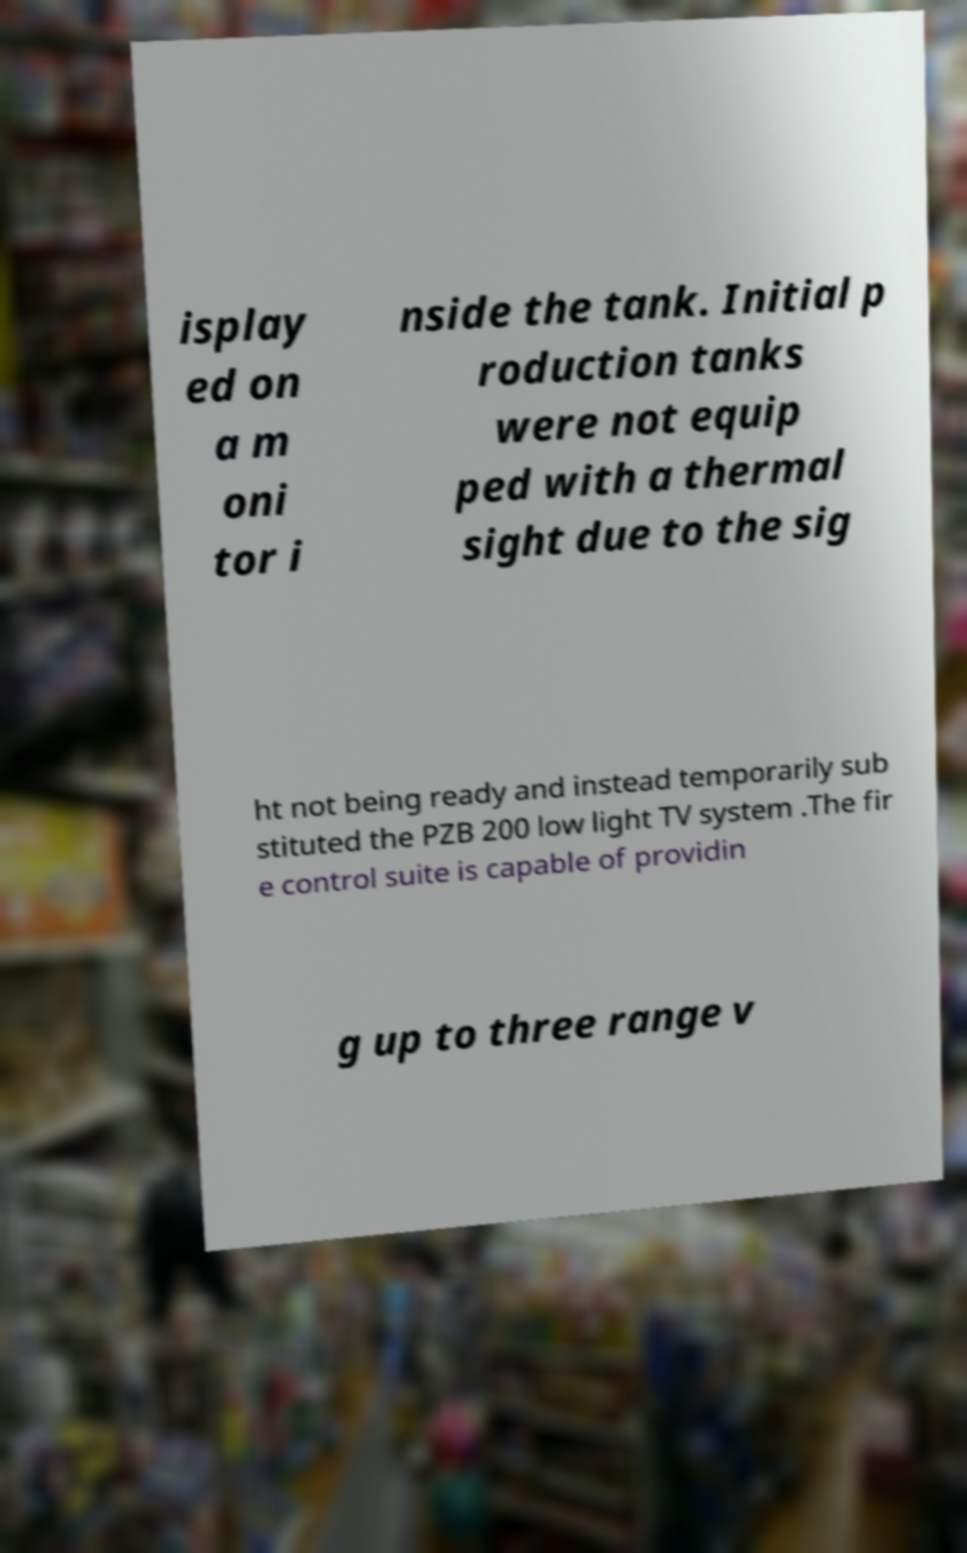Could you extract and type out the text from this image? isplay ed on a m oni tor i nside the tank. Initial p roduction tanks were not equip ped with a thermal sight due to the sig ht not being ready and instead temporarily sub stituted the PZB 200 low light TV system .The fir e control suite is capable of providin g up to three range v 